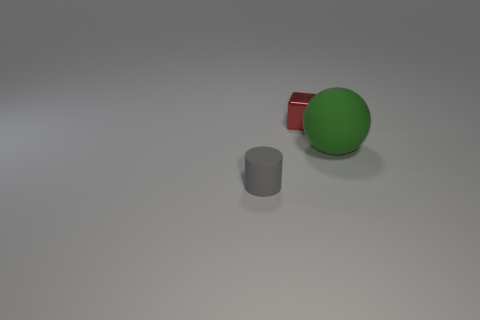The small gray thing is what shape?
Provide a short and direct response. Cylinder. There is a rubber object that is right of the gray cylinder; is its shape the same as the gray thing?
Ensure brevity in your answer.  No. Are there more small gray cylinders behind the gray object than large green matte spheres that are behind the matte sphere?
Your answer should be compact. No. How many other things are the same size as the red shiny object?
Keep it short and to the point. 1. Does the large object have the same shape as the object in front of the green thing?
Give a very brief answer. No. How many rubber objects are either tiny gray cylinders or big balls?
Provide a succinct answer. 2. Are there any large cubes that have the same color as the cylinder?
Your answer should be compact. No. Are there any big cyan metallic cubes?
Make the answer very short. No. Do the red shiny thing and the green rubber thing have the same shape?
Give a very brief answer. No. How many small objects are green rubber blocks or balls?
Provide a short and direct response. 0. 